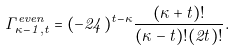Convert formula to latex. <formula><loc_0><loc_0><loc_500><loc_500>\Gamma ^ { e v e n } _ { \kappa - 1 , t } = ( - 2 4 ) ^ { t - \kappa } \frac { ( \kappa + t ) ! } { ( \kappa - t ) ! ( 2 t ) ! } .</formula> 